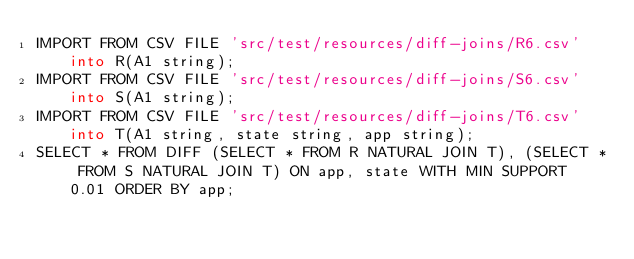Convert code to text. <code><loc_0><loc_0><loc_500><loc_500><_SQL_>IMPORT FROM CSV FILE 'src/test/resources/diff-joins/R6.csv' into R(A1 string);
IMPORT FROM CSV FILE 'src/test/resources/diff-joins/S6.csv' into S(A1 string);
IMPORT FROM CSV FILE 'src/test/resources/diff-joins/T6.csv' into T(A1 string, state string, app string);
SELECT * FROM DIFF (SELECT * FROM R NATURAL JOIN T), (SELECT * FROM S NATURAL JOIN T) ON app, state WITH MIN SUPPORT 0.01 ORDER BY app;
</code> 